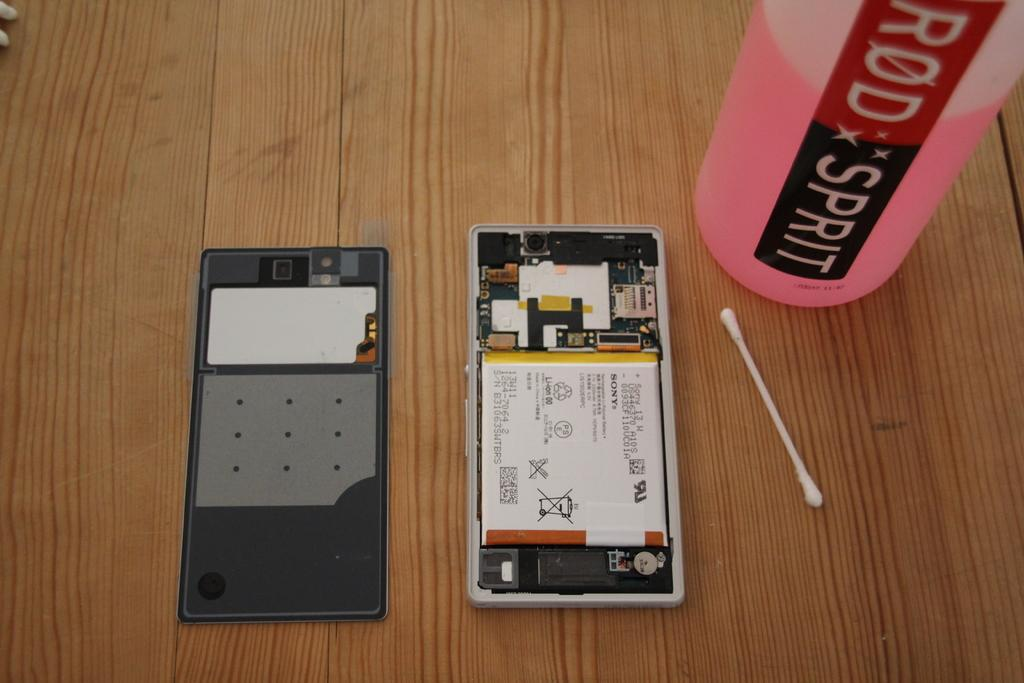<image>
Create a compact narrative representing the image presented. A cotton bud next to a half full bottle which reads Rod Spirit 